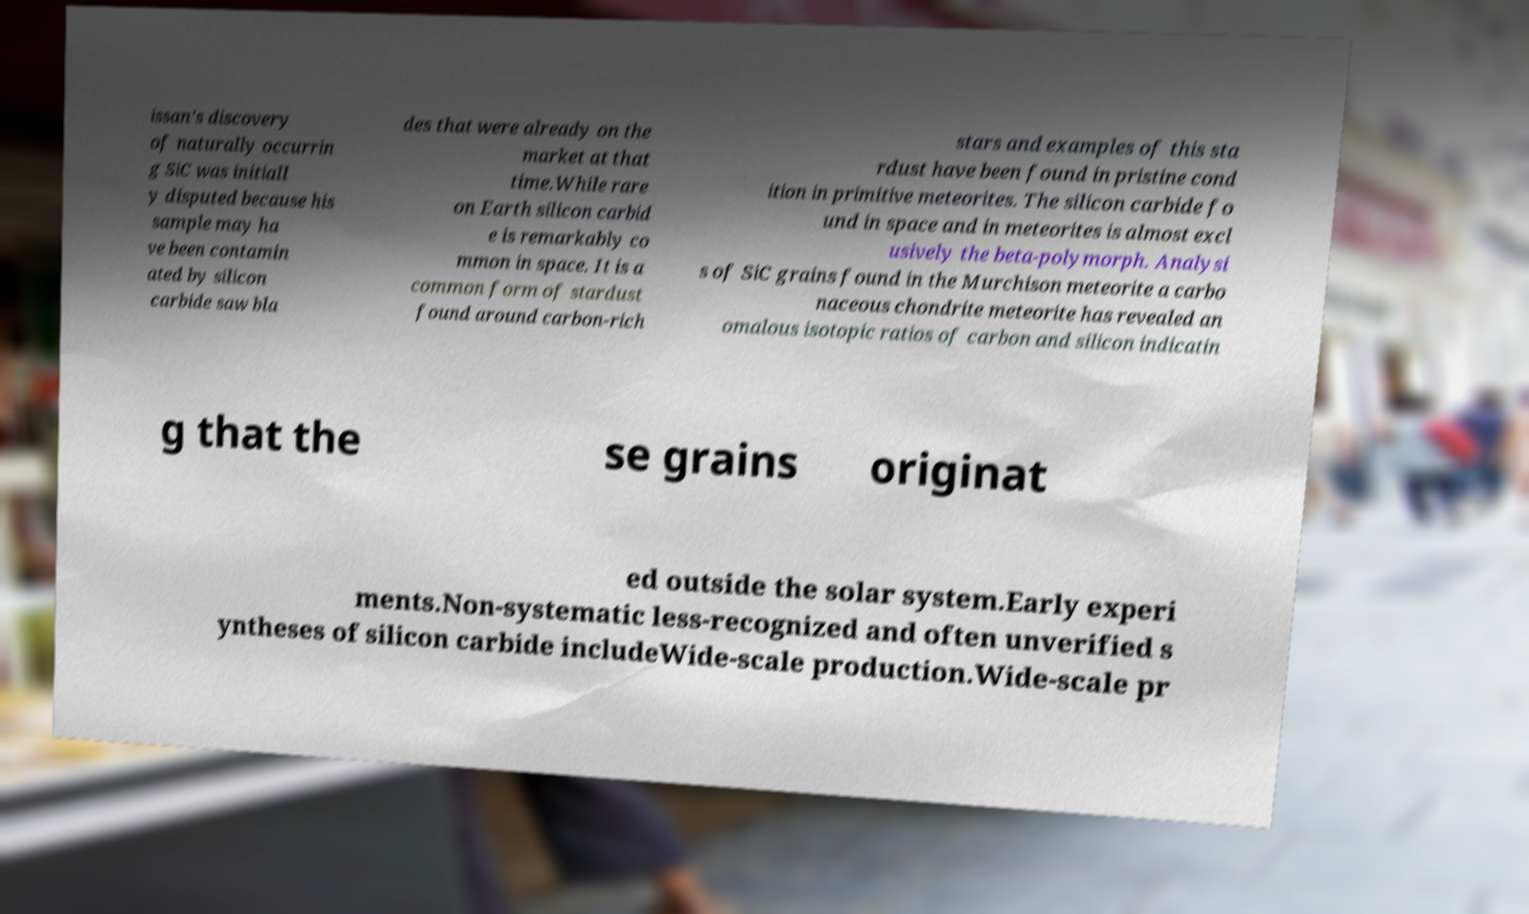Can you read and provide the text displayed in the image?This photo seems to have some interesting text. Can you extract and type it out for me? issan's discovery of naturally occurrin g SiC was initiall y disputed because his sample may ha ve been contamin ated by silicon carbide saw bla des that were already on the market at that time.While rare on Earth silicon carbid e is remarkably co mmon in space. It is a common form of stardust found around carbon-rich stars and examples of this sta rdust have been found in pristine cond ition in primitive meteorites. The silicon carbide fo und in space and in meteorites is almost excl usively the beta-polymorph. Analysi s of SiC grains found in the Murchison meteorite a carbo naceous chondrite meteorite has revealed an omalous isotopic ratios of carbon and silicon indicatin g that the se grains originat ed outside the solar system.Early experi ments.Non-systematic less-recognized and often unverified s yntheses of silicon carbide includeWide-scale production.Wide-scale pr 